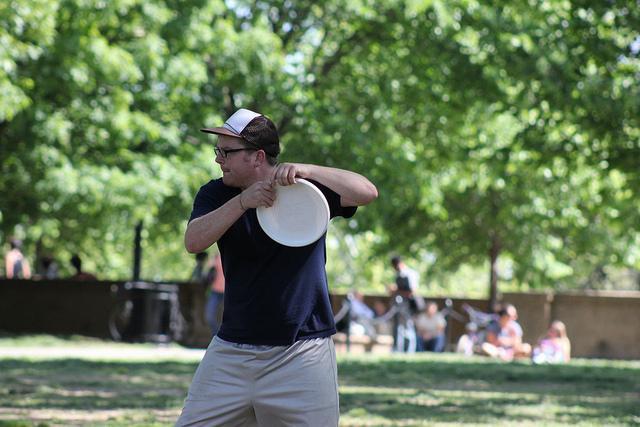How many people can be seen?
Give a very brief answer. 2. How many slices of pizza are left?
Give a very brief answer. 0. 